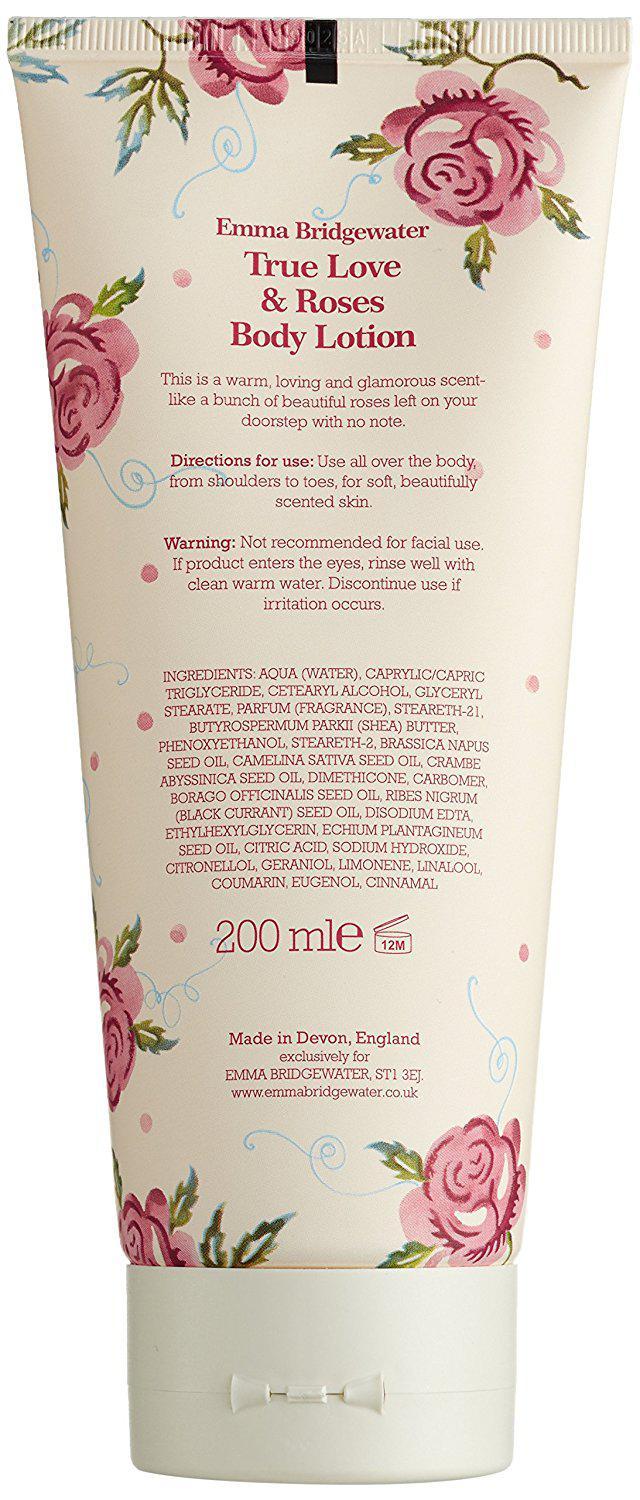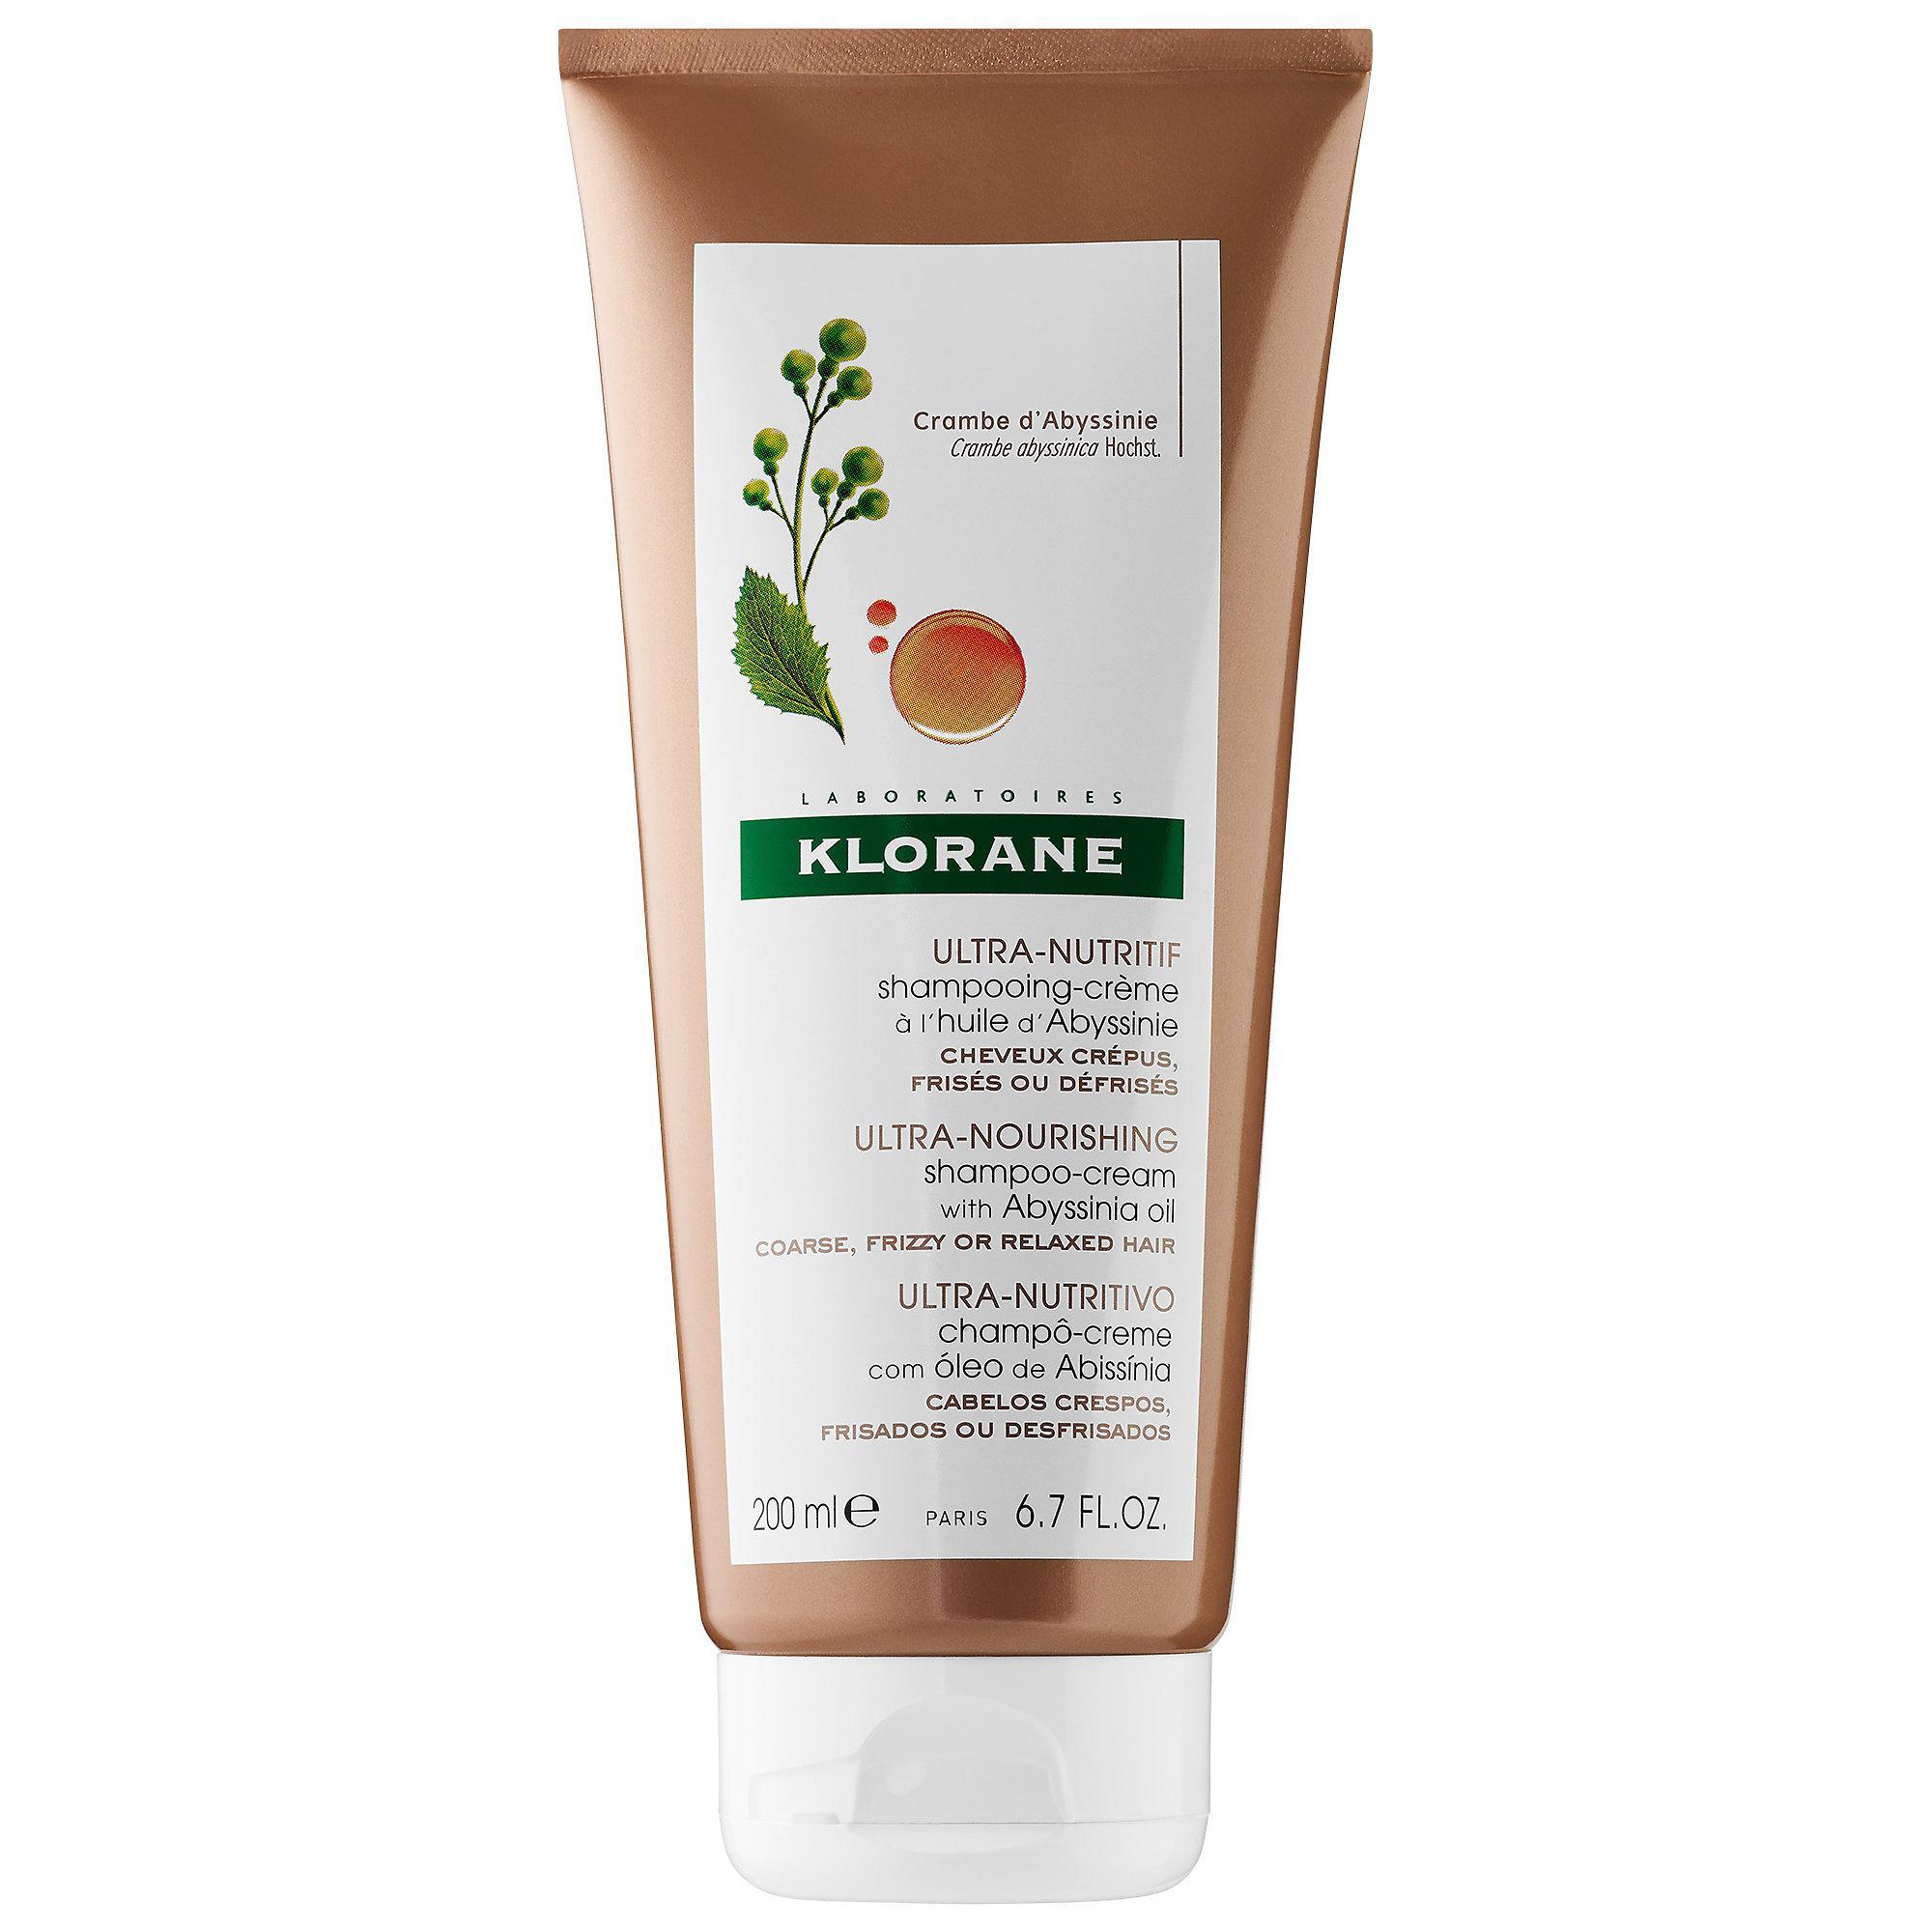The first image is the image on the left, the second image is the image on the right. For the images shown, is this caption "The right image shows a single product, which is decorated with lavender flowers, and left and right images show products in the same shape and applicator formats." true? Answer yes or no. No. The first image is the image on the left, the second image is the image on the right. Analyze the images presented: Is the assertion "Two containers of body wash have their cap on the bottom." valid? Answer yes or no. Yes. 